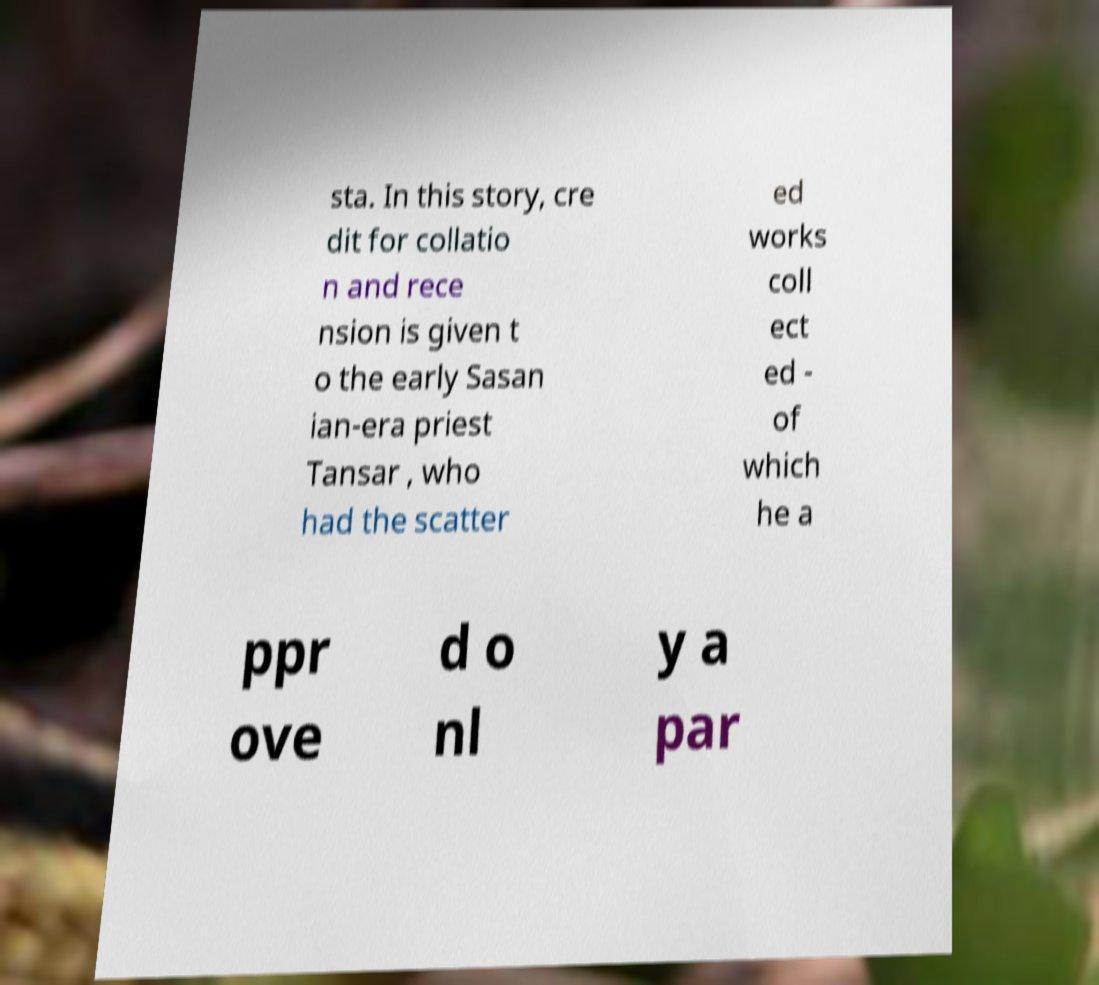Could you extract and type out the text from this image? sta. In this story, cre dit for collatio n and rece nsion is given t o the early Sasan ian-era priest Tansar , who had the scatter ed works coll ect ed - of which he a ppr ove d o nl y a par 